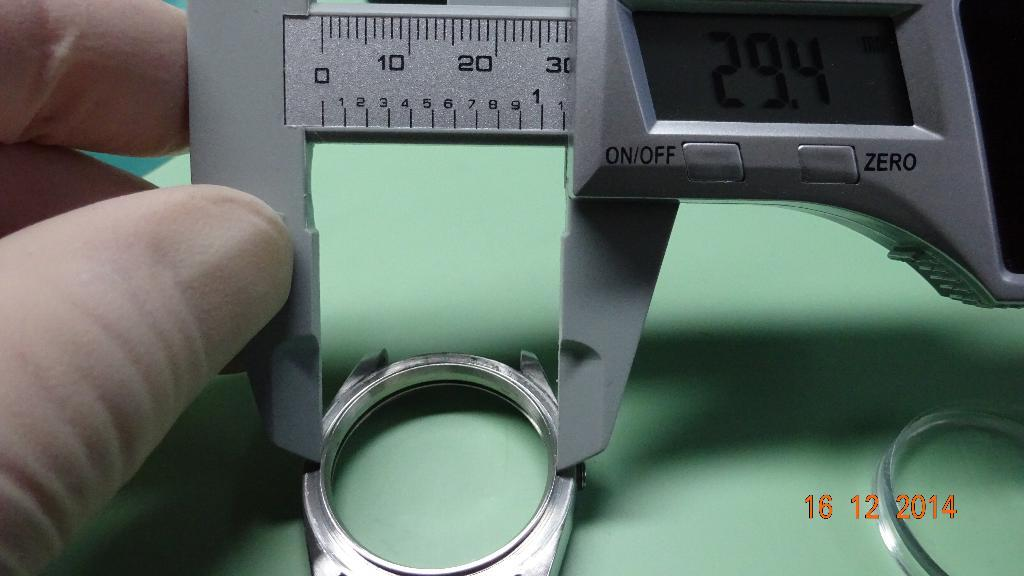What is the person in the image doing? The person is holding vernier calipers in the image. What object is the person likely using for a specific purpose? The person is likely using the vernier calipers for measuring or inspecting something. What is located on the table in the image? There is a ring on the table in the image. Where is the birthday cake located in the image? There is no birthday cake present in the image. What type of kettle is visible on the table next to the ring? There is no kettle present in the image. 